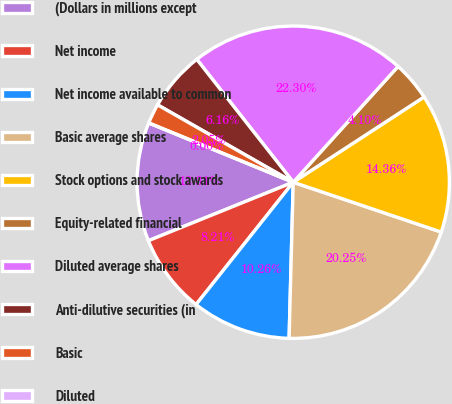Convert chart. <chart><loc_0><loc_0><loc_500><loc_500><pie_chart><fcel>(Dollars in millions except<fcel>Net income<fcel>Net income available to common<fcel>Basic average shares<fcel>Stock options and stock awards<fcel>Equity-related financial<fcel>Diluted average shares<fcel>Anti-dilutive securities (in<fcel>Basic<fcel>Diluted<nl><fcel>12.31%<fcel>8.21%<fcel>10.26%<fcel>20.25%<fcel>14.36%<fcel>4.1%<fcel>22.3%<fcel>6.16%<fcel>2.05%<fcel>0.0%<nl></chart> 